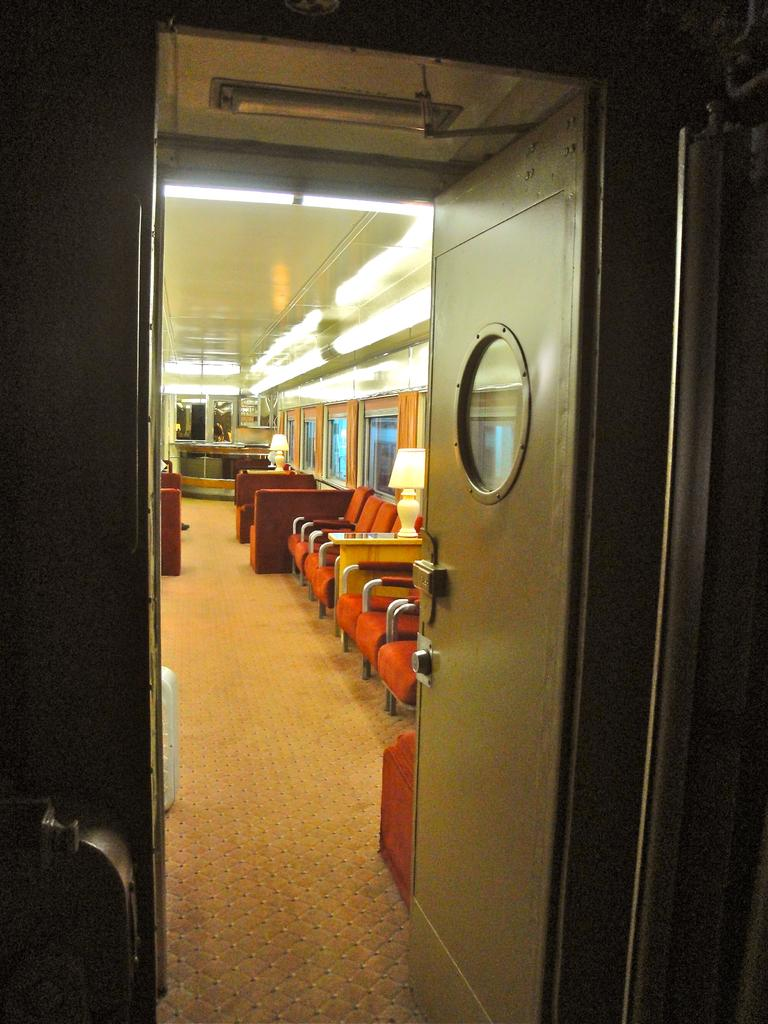What is the main object visible in the image? There is a door in the image. What can be seen inside the door? There are chairs inside the door. What color are the chairs? The chairs are orange in color. What is visible at the top of the image? There are lights visible at the top of the image. How does the person in the image grip their hat while walking? There is no person or hat present in the image, so it is not possible to answer that question. 